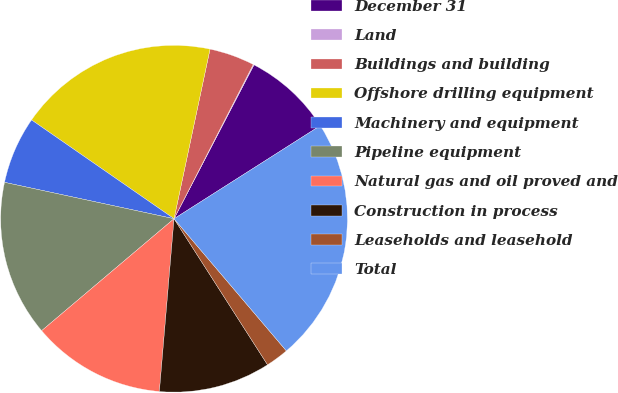Convert chart. <chart><loc_0><loc_0><loc_500><loc_500><pie_chart><fcel>December 31<fcel>Land<fcel>Buildings and building<fcel>Offshore drilling equipment<fcel>Machinery and equipment<fcel>Pipeline equipment<fcel>Natural gas and oil proved and<fcel>Construction in process<fcel>Leaseholds and leasehold<fcel>Total<nl><fcel>8.35%<fcel>0.08%<fcel>4.22%<fcel>18.68%<fcel>6.28%<fcel>14.54%<fcel>12.48%<fcel>10.41%<fcel>2.15%<fcel>22.81%<nl></chart> 